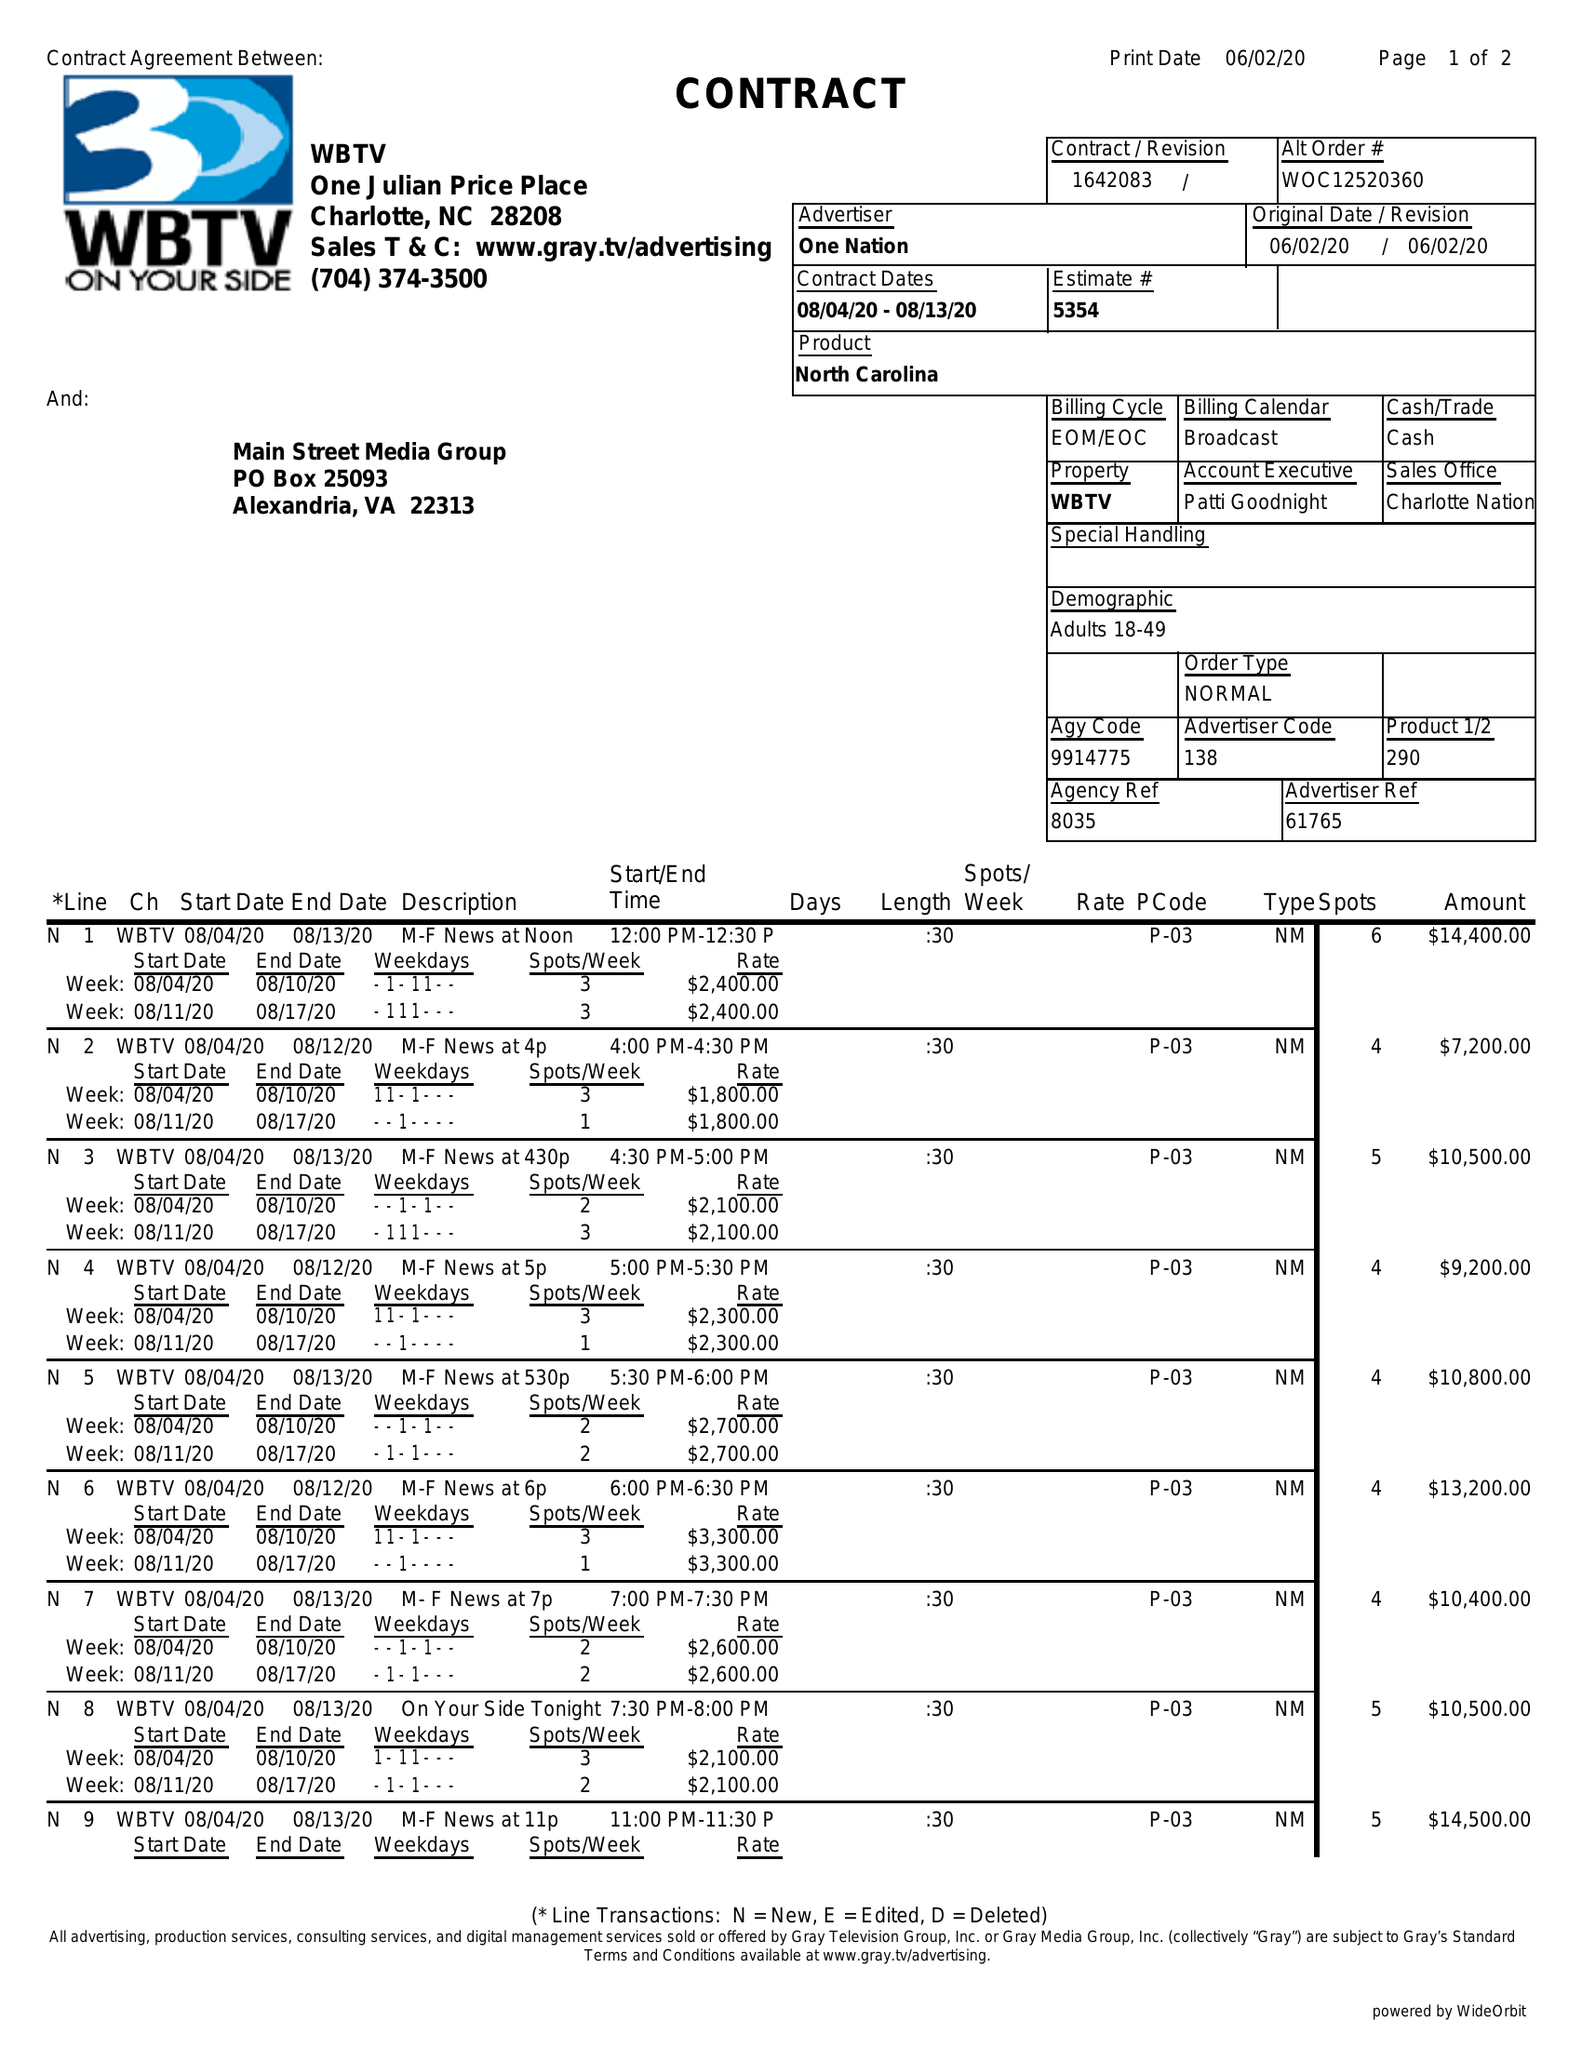What is the value for the contract_num?
Answer the question using a single word or phrase. 1642083 